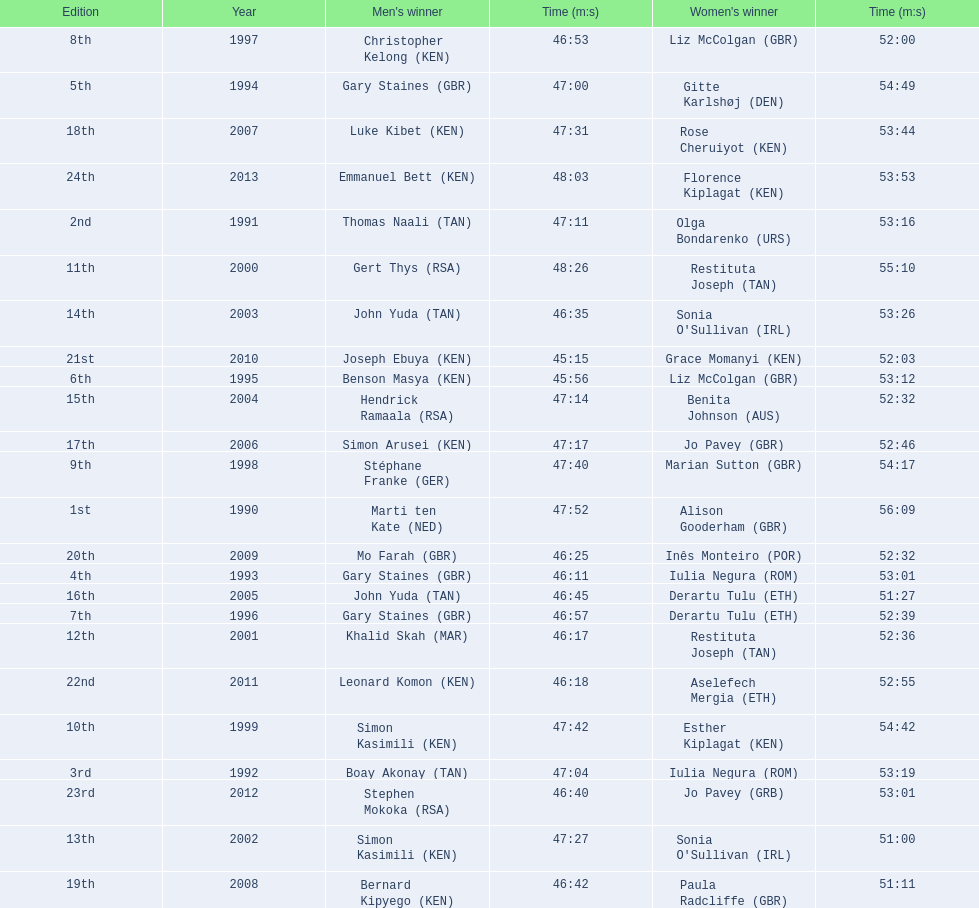What years were the races held? 1990, 1991, 1992, 1993, 1994, 1995, 1996, 1997, 1998, 1999, 2000, 2001, 2002, 2003, 2004, 2005, 2006, 2007, 2008, 2009, 2010, 2011, 2012, 2013. Who was the woman's winner of the 2003 race? Sonia O'Sullivan (IRL). What was her time? 53:26. 